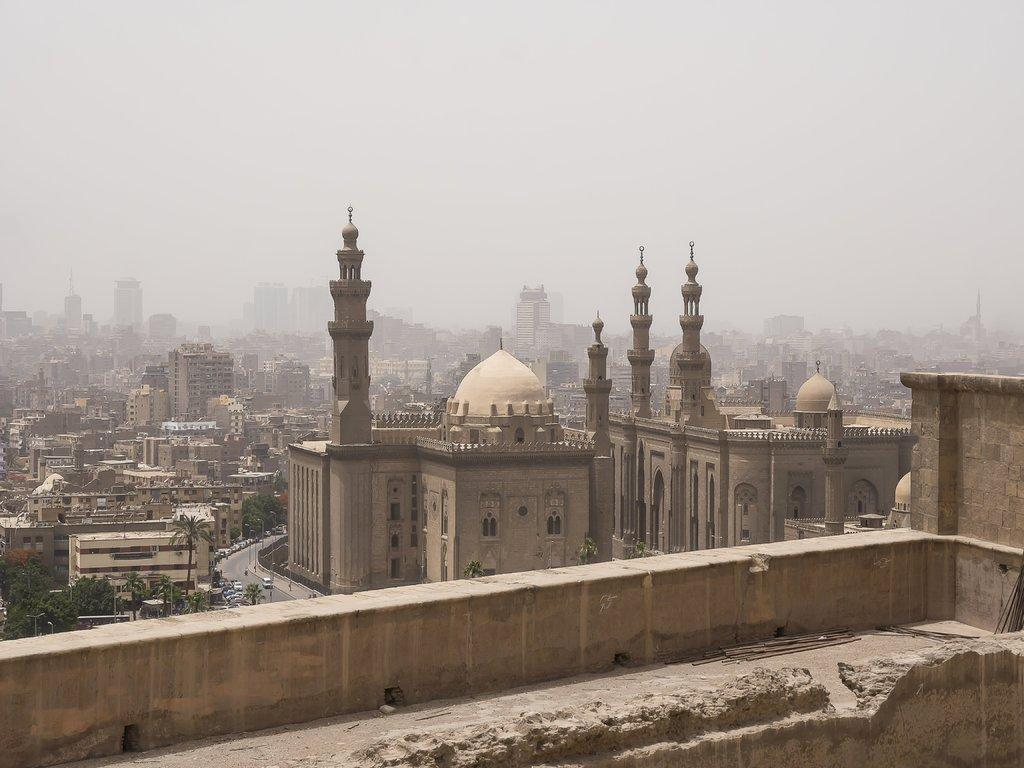What type of structures can be seen in the image? There are buildings in the image. What other natural elements are present in the image? There are trees in the image. What mode of transportation can be seen on the road in the image? There are vehicles on the road in the image. What direction does the memory travel in the image? There is no memory present in the image, as it is a visual representation of a scene and not a mental construct. 